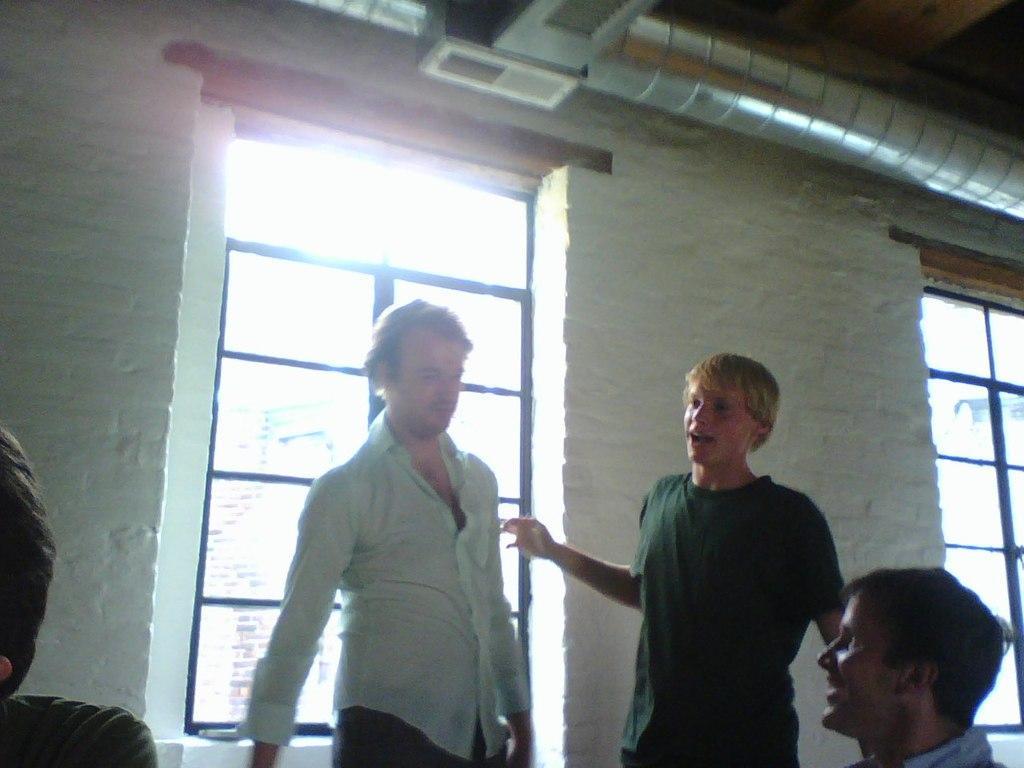How would you summarize this image in a sentence or two? In the picture we can see a man and a boy standing and man is wearing a white shirt and boy is wearing a green T-shirt and front of them, we can see a person sitting and watching them and in the background we can see a wall with windows and to the ceiling we can see the air exhaust pipe. 